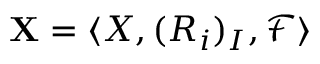<formula> <loc_0><loc_0><loc_500><loc_500>X = \langle X , ( R _ { i } ) _ { I } , { \mathcal { F } } \rangle</formula> 